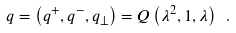<formula> <loc_0><loc_0><loc_500><loc_500>q = \left ( q ^ { + } , q ^ { - } , { q } _ { \perp } \right ) = Q \left ( \lambda ^ { 2 } , 1 , \lambda \right ) \ .</formula> 